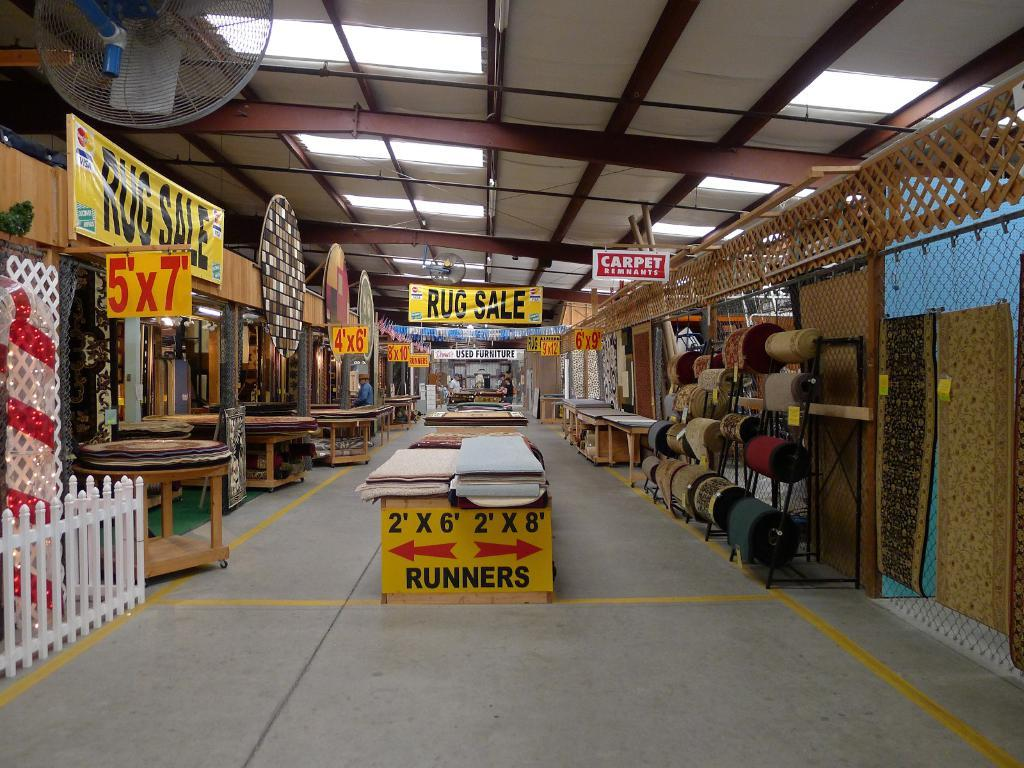<image>
Provide a brief description of the given image. Ware house showing a sign in front that says "Runners". 